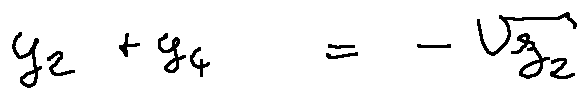<formula> <loc_0><loc_0><loc_500><loc_500>y _ { 2 } + y _ { 4 } = - \sqrt { z _ { 2 } }</formula> 